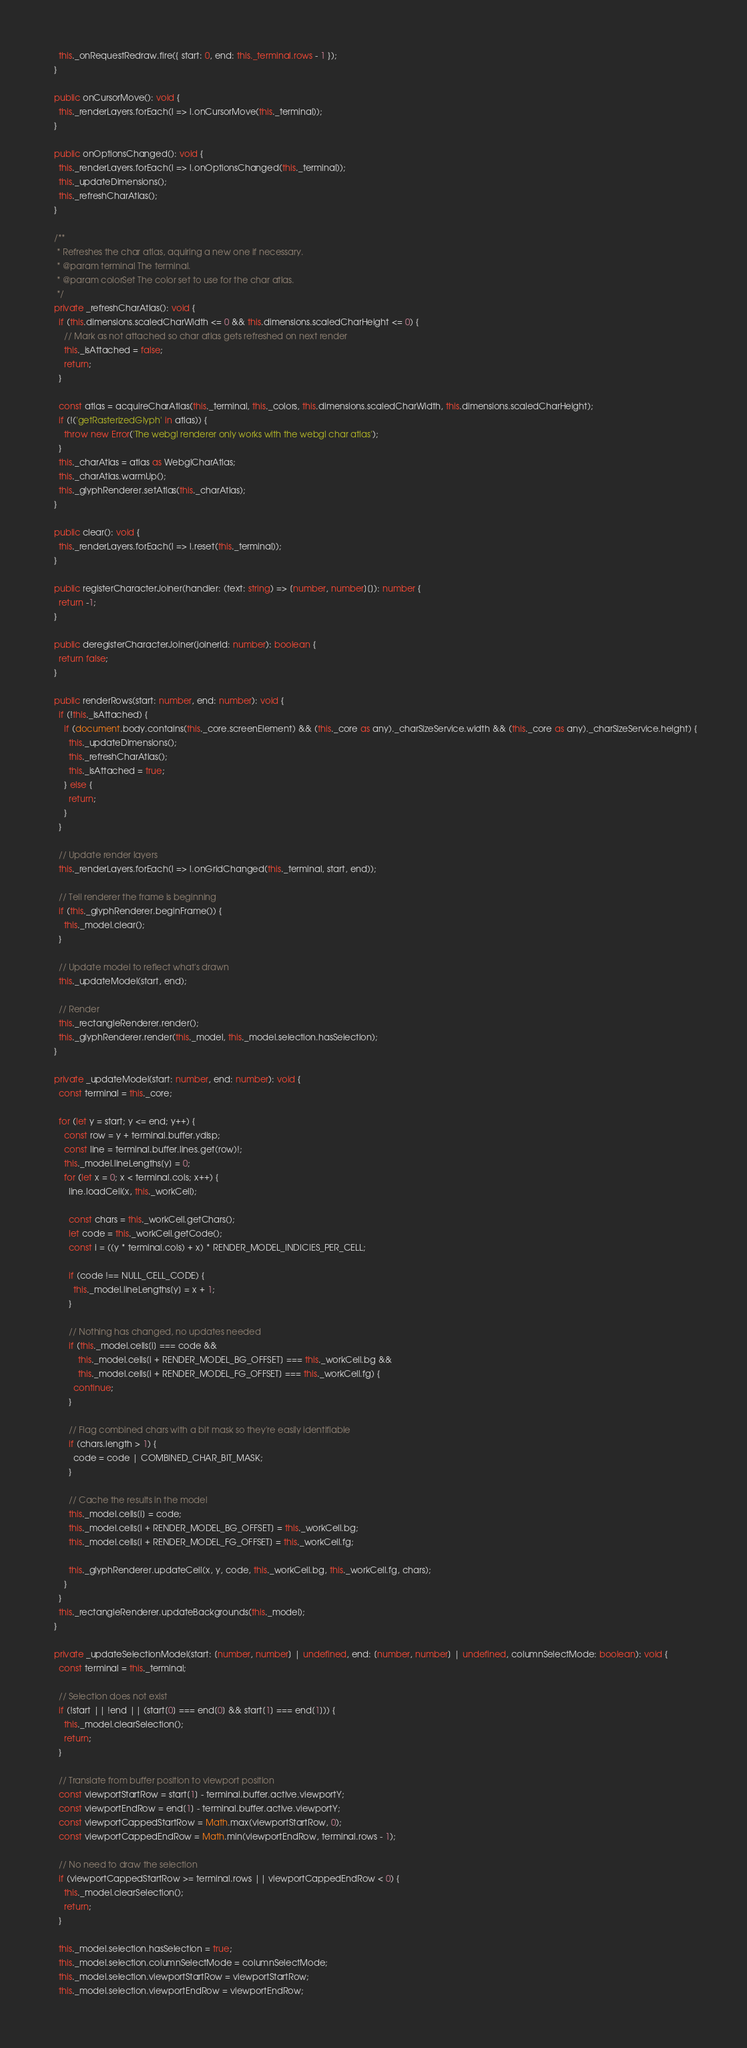<code> <loc_0><loc_0><loc_500><loc_500><_TypeScript_>    this._onRequestRedraw.fire({ start: 0, end: this._terminal.rows - 1 });
  }

  public onCursorMove(): void {
    this._renderLayers.forEach(l => l.onCursorMove(this._terminal));
  }

  public onOptionsChanged(): void {
    this._renderLayers.forEach(l => l.onOptionsChanged(this._terminal));
    this._updateDimensions();
    this._refreshCharAtlas();
  }

  /**
   * Refreshes the char atlas, aquiring a new one if necessary.
   * @param terminal The terminal.
   * @param colorSet The color set to use for the char atlas.
   */
  private _refreshCharAtlas(): void {
    if (this.dimensions.scaledCharWidth <= 0 && this.dimensions.scaledCharHeight <= 0) {
      // Mark as not attached so char atlas gets refreshed on next render
      this._isAttached = false;
      return;
    }

    const atlas = acquireCharAtlas(this._terminal, this._colors, this.dimensions.scaledCharWidth, this.dimensions.scaledCharHeight);
    if (!('getRasterizedGlyph' in atlas)) {
      throw new Error('The webgl renderer only works with the webgl char atlas');
    }
    this._charAtlas = atlas as WebglCharAtlas;
    this._charAtlas.warmUp();
    this._glyphRenderer.setAtlas(this._charAtlas);
  }

  public clear(): void {
    this._renderLayers.forEach(l => l.reset(this._terminal));
  }

  public registerCharacterJoiner(handler: (text: string) => [number, number][]): number {
    return -1;
  }

  public deregisterCharacterJoiner(joinerId: number): boolean {
    return false;
  }

  public renderRows(start: number, end: number): void {
    if (!this._isAttached) {
      if (document.body.contains(this._core.screenElement) && (this._core as any)._charSizeService.width && (this._core as any)._charSizeService.height) {
        this._updateDimensions();
        this._refreshCharAtlas();
        this._isAttached = true;
      } else {
        return;
      }
    }

    // Update render layers
    this._renderLayers.forEach(l => l.onGridChanged(this._terminal, start, end));

    // Tell renderer the frame is beginning
    if (this._glyphRenderer.beginFrame()) {
      this._model.clear();
    }

    // Update model to reflect what's drawn
    this._updateModel(start, end);

    // Render
    this._rectangleRenderer.render();
    this._glyphRenderer.render(this._model, this._model.selection.hasSelection);
  }

  private _updateModel(start: number, end: number): void {
    const terminal = this._core;

    for (let y = start; y <= end; y++) {
      const row = y + terminal.buffer.ydisp;
      const line = terminal.buffer.lines.get(row)!;
      this._model.lineLengths[y] = 0;
      for (let x = 0; x < terminal.cols; x++) {
        line.loadCell(x, this._workCell);

        const chars = this._workCell.getChars();
        let code = this._workCell.getCode();
        const i = ((y * terminal.cols) + x) * RENDER_MODEL_INDICIES_PER_CELL;

        if (code !== NULL_CELL_CODE) {
          this._model.lineLengths[y] = x + 1;
        }

        // Nothing has changed, no updates needed
        if (this._model.cells[i] === code &&
            this._model.cells[i + RENDER_MODEL_BG_OFFSET] === this._workCell.bg &&
            this._model.cells[i + RENDER_MODEL_FG_OFFSET] === this._workCell.fg) {
          continue;
        }

        // Flag combined chars with a bit mask so they're easily identifiable
        if (chars.length > 1) {
          code = code | COMBINED_CHAR_BIT_MASK;
        }

        // Cache the results in the model
        this._model.cells[i] = code;
        this._model.cells[i + RENDER_MODEL_BG_OFFSET] = this._workCell.bg;
        this._model.cells[i + RENDER_MODEL_FG_OFFSET] = this._workCell.fg;

        this._glyphRenderer.updateCell(x, y, code, this._workCell.bg, this._workCell.fg, chars);
      }
    }
    this._rectangleRenderer.updateBackgrounds(this._model);
  }

  private _updateSelectionModel(start: [number, number] | undefined, end: [number, number] | undefined, columnSelectMode: boolean): void {
    const terminal = this._terminal;

    // Selection does not exist
    if (!start || !end || (start[0] === end[0] && start[1] === end[1])) {
      this._model.clearSelection();
      return;
    }

    // Translate from buffer position to viewport position
    const viewportStartRow = start[1] - terminal.buffer.active.viewportY;
    const viewportEndRow = end[1] - terminal.buffer.active.viewportY;
    const viewportCappedStartRow = Math.max(viewportStartRow, 0);
    const viewportCappedEndRow = Math.min(viewportEndRow, terminal.rows - 1);

    // No need to draw the selection
    if (viewportCappedStartRow >= terminal.rows || viewportCappedEndRow < 0) {
      this._model.clearSelection();
      return;
    }

    this._model.selection.hasSelection = true;
    this._model.selection.columnSelectMode = columnSelectMode;
    this._model.selection.viewportStartRow = viewportStartRow;
    this._model.selection.viewportEndRow = viewportEndRow;</code> 